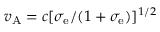<formula> <loc_0><loc_0><loc_500><loc_500>v _ { A } = c [ \sigma _ { e } / ( 1 + \sigma _ { e } ) ] ^ { 1 / 2 }</formula> 